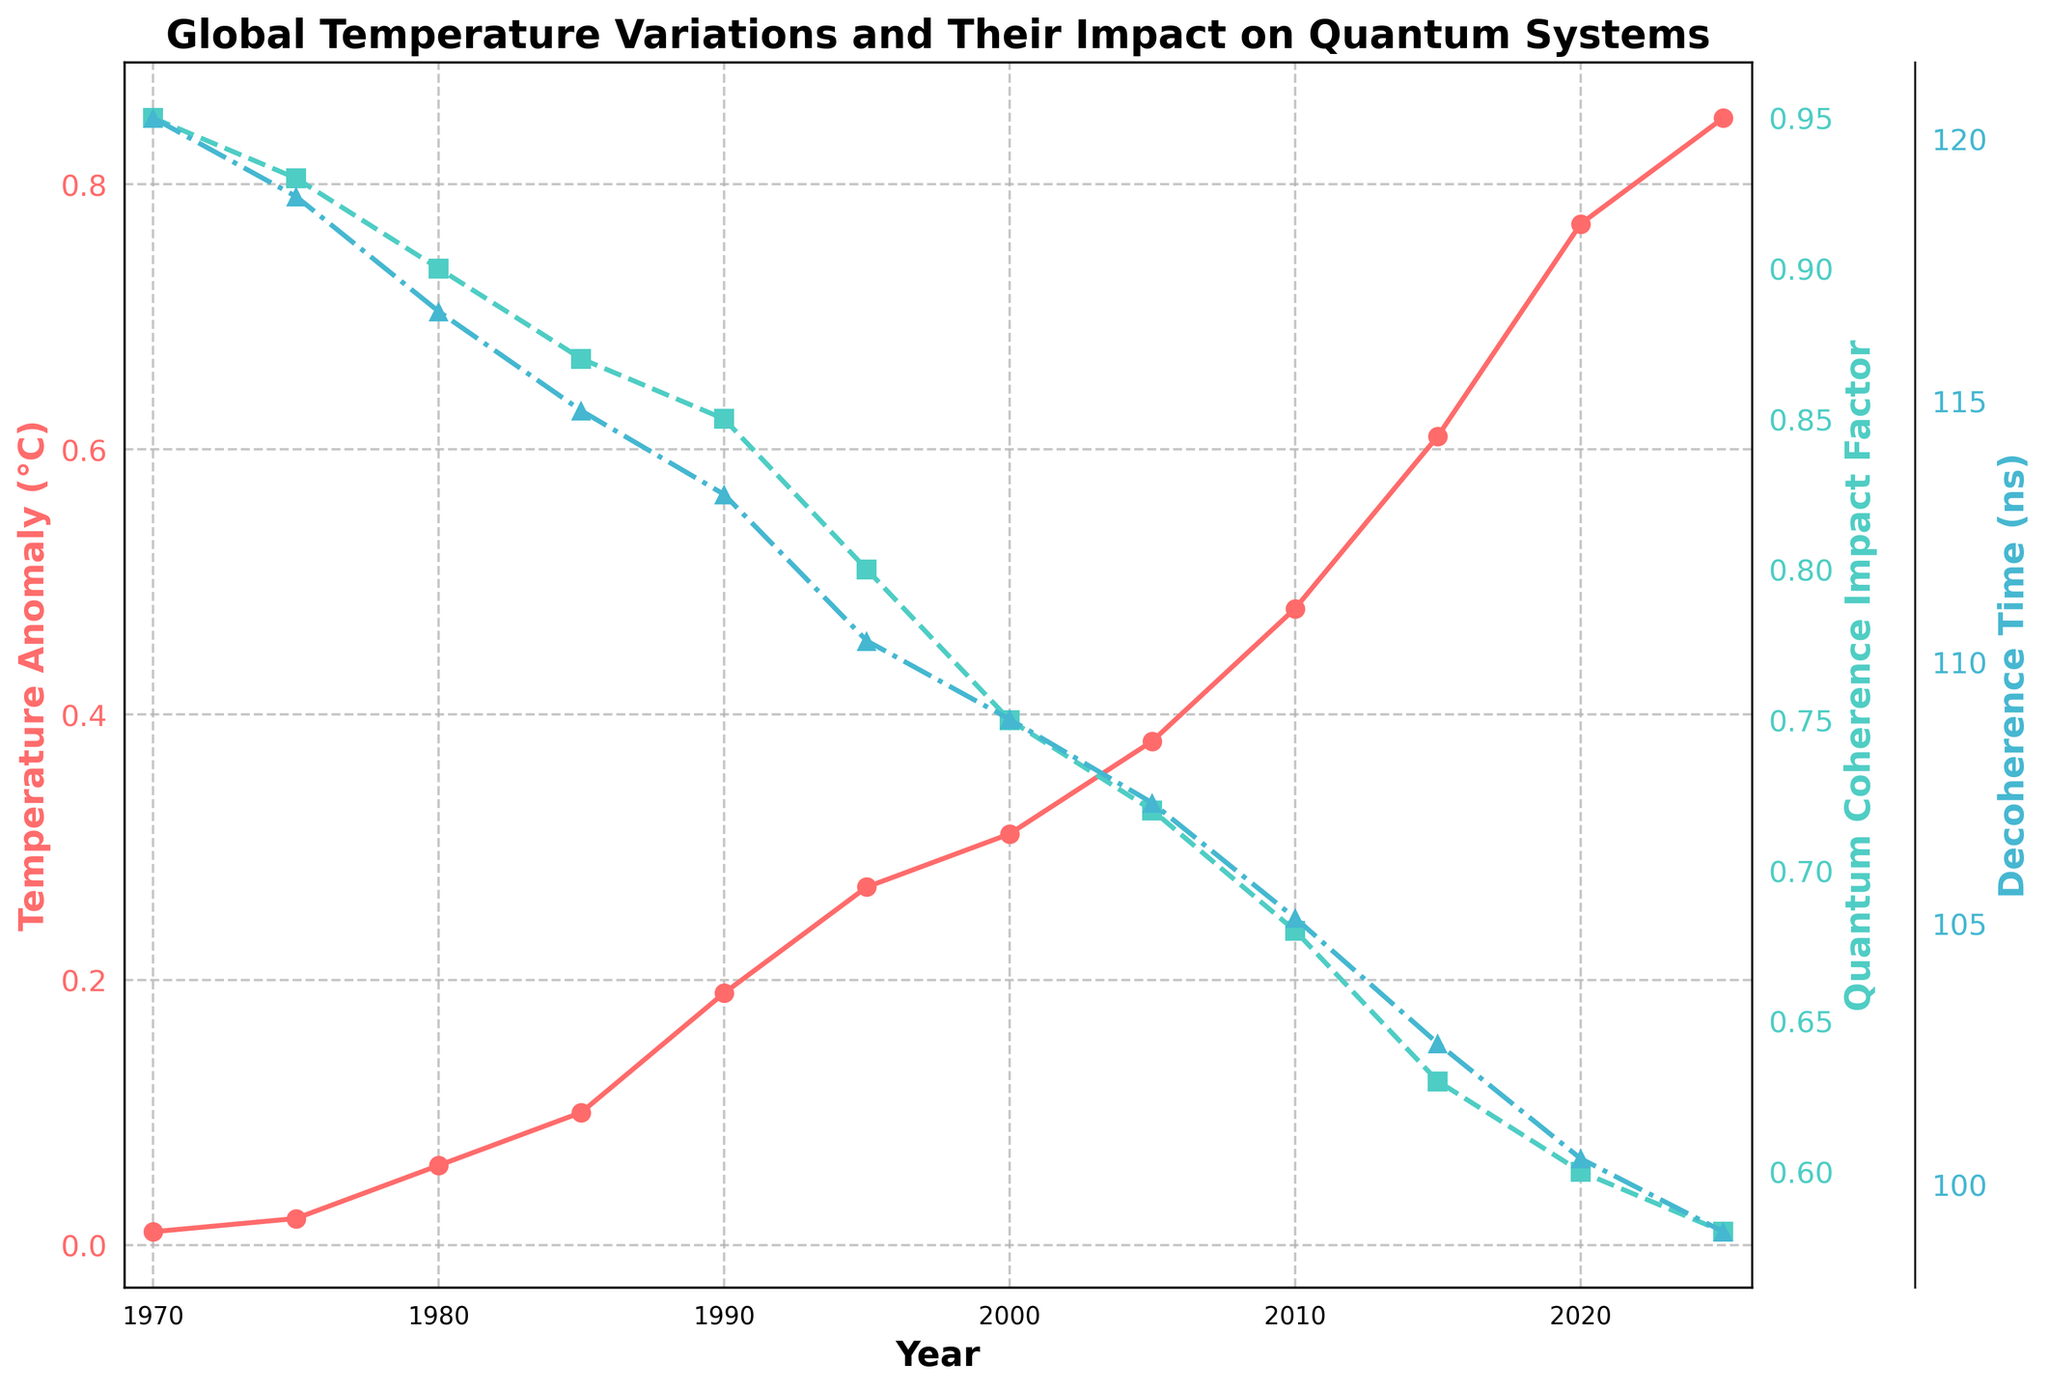What is the title of the figure? The title of the figure is displayed at the top center above the plot. It is visually distinguished by its font size and boldness. The title reads: "Global Temperature Variations and Their Impact on Quantum Systems."
Answer: Global Temperature Variations and Their Impact on Quantum Systems How has the Global Average Temperature Anomaly changed from 1970 to 2025? To determine the change in the Global Average Temperature Anomaly from 1970 to 2025, subtract the anomaly in 1970 from the anomaly in 2025. The anomaly in 1970 is 0.01°C, and in 2025 it is 0.85°C. The change is 0.85 - 0.01 = 0.84°C.
Answer: Increased by 0.84°C What is the trend in the Quantum Coherence Impact Factor over the years? By observing the plot of the Quantum Coherence Impact Factor (identified by a dashed line with square markers in green color), we see a clear downward trend from 0.95 in 1970 to 0.58 in 2025.
Answer: Downward Trend Which year has the highest Decoherence Time? By examining the plot of the Decoherence Time (identified by a dashed-dotted line with triangle markers in blue color), we notice that it is the highest in the year 1970 at 120.4 ns.
Answer: 1970 How does the Decoherence Time in 2025 compare to that in 1975? To compare the Decoherence Time between 2025 and 1975, note the values from the plot. In 2025 it is 99.1 ns and in 1975 it is 118.9 ns. Therefore, the Decoherence Time in 2025 is shorter than in 1975.
Answer: Shorter Which variable shows the steepest rate of change over the years? By visually comparing the three trends on the plot, the Global Average Temperature Anomaly shows the steepest rate of change as it rises sharply over the years from 0.01°C in 1970 to 0.85°C in 2025.
Answer: Global Average Temperature Anomaly What is the mean Quantum Coherence Impact Factor between 1980 and 2005? To find the mean Quantum Coherence Impact Factor, sum the values from 1980 (0.90), 1985 (0.87), 1990 (0.85), 1995 (0.80), 2000 (0.75), and 2005 (0.72), then divide by the number of years: (0.90 + 0.87 + 0.85 + 0.80 + 0.75 + 0.72) / 6 = 4.89 / 6.
Answer: 0.815 How does the trend in Global Average Temperature Anomaly compare to the trend in Decoherence Time? Comparing the trends, the Global Average Temperature Anomaly shows an increasing trend over the years, while the Decoherence Time shows a decreasing trend. These trends are opposite.
Answer: Opposite Trends What are the colors used for the three plotted variables? The plot uses different colors to represent each variable: the Global Average Temperature Anomaly is in red, the Quantum Coherence Impact Factor is in green, and the Decoherence Time is in blue.
Answer: Red, Green, Blue 